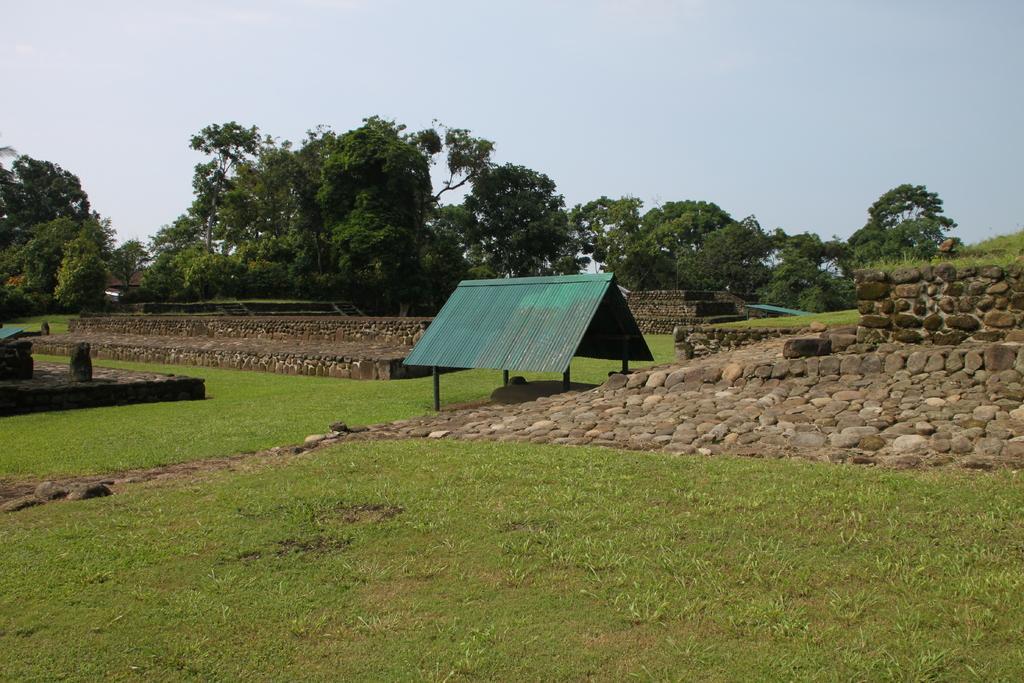Describe this image in one or two sentences. At the bottom of the picture, we see the grass and beside that, we see stones and a shed in green color. In the background, there are trees and staircase. At the top of the picture, we see the sky. 